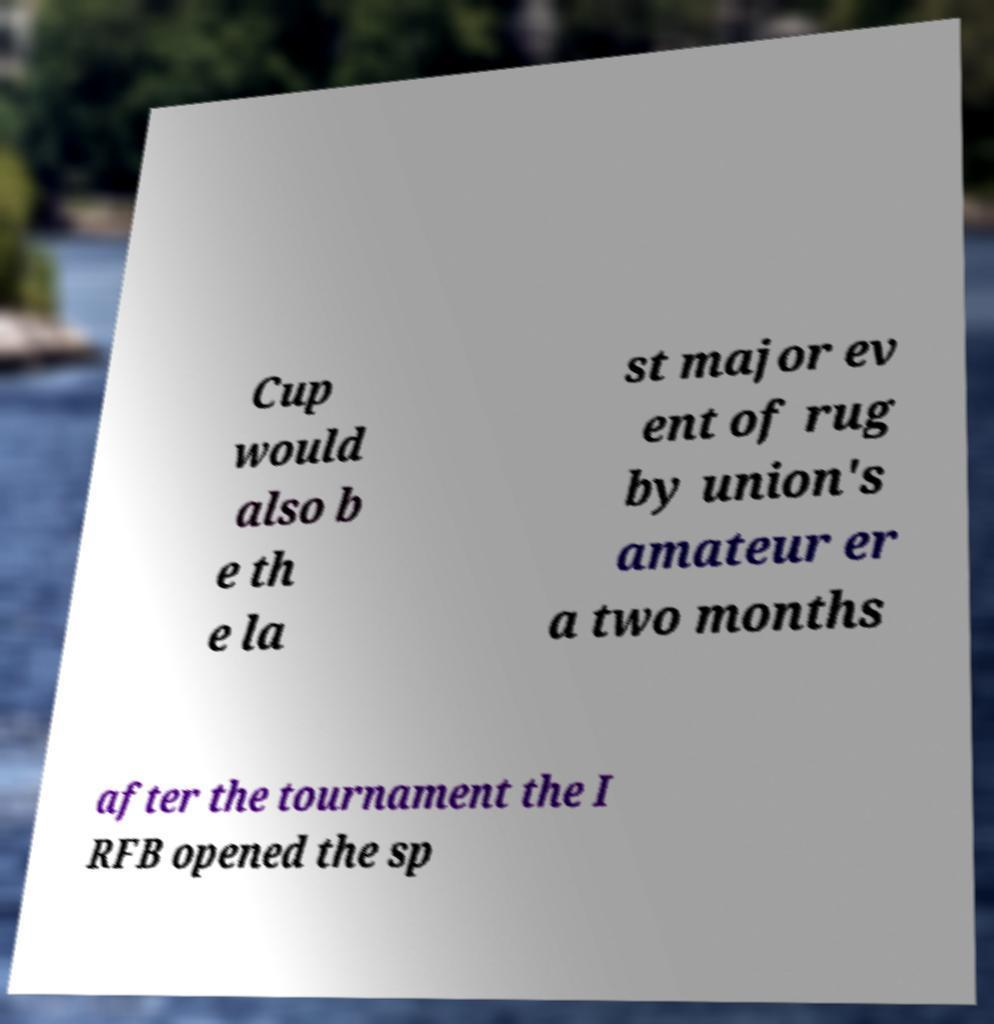Please identify and transcribe the text found in this image. Cup would also b e th e la st major ev ent of rug by union's amateur er a two months after the tournament the I RFB opened the sp 